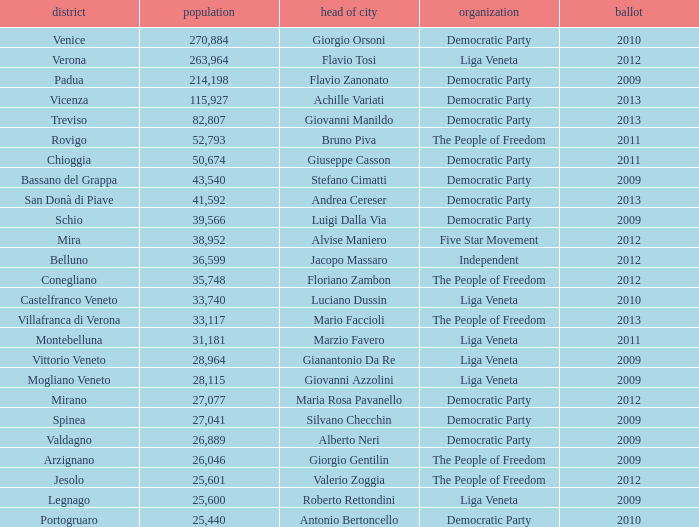How many elections had more than 36,599 inhabitants when Mayor was giovanni manildo? 1.0. 